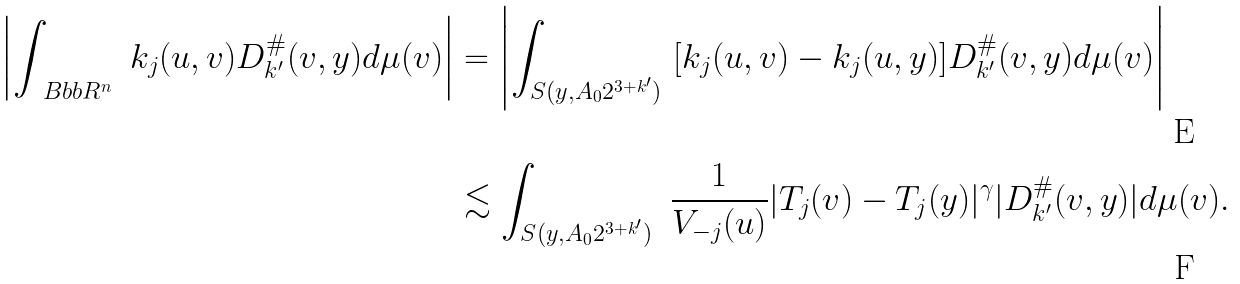<formula> <loc_0><loc_0><loc_500><loc_500>\left | \int _ { \ B b b R ^ { n } } \ k _ { j } ( u , v ) D _ { k ^ { \prime } } ^ { \# } ( v , y ) d \mu ( v ) \right | & = \left | \int _ { S ( y , A _ { 0 } 2 ^ { 3 + k ^ { \prime } } ) } \ [ k _ { j } ( u , v ) - k _ { j } ( u , y ) ] D _ { k ^ { \prime } } ^ { \# } ( v , y ) d \mu ( v ) \right | \\ & \lesssim \int _ { S ( y , A _ { 0 } 2 ^ { 3 + k ^ { \prime } } ) } \ \frac { 1 } { V _ { - j } ( u ) } | T _ { j } ( v ) - T _ { j } ( y ) | ^ { \gamma } | D _ { k ^ { \prime } } ^ { \# } ( v , y ) | d \mu ( v ) .</formula> 